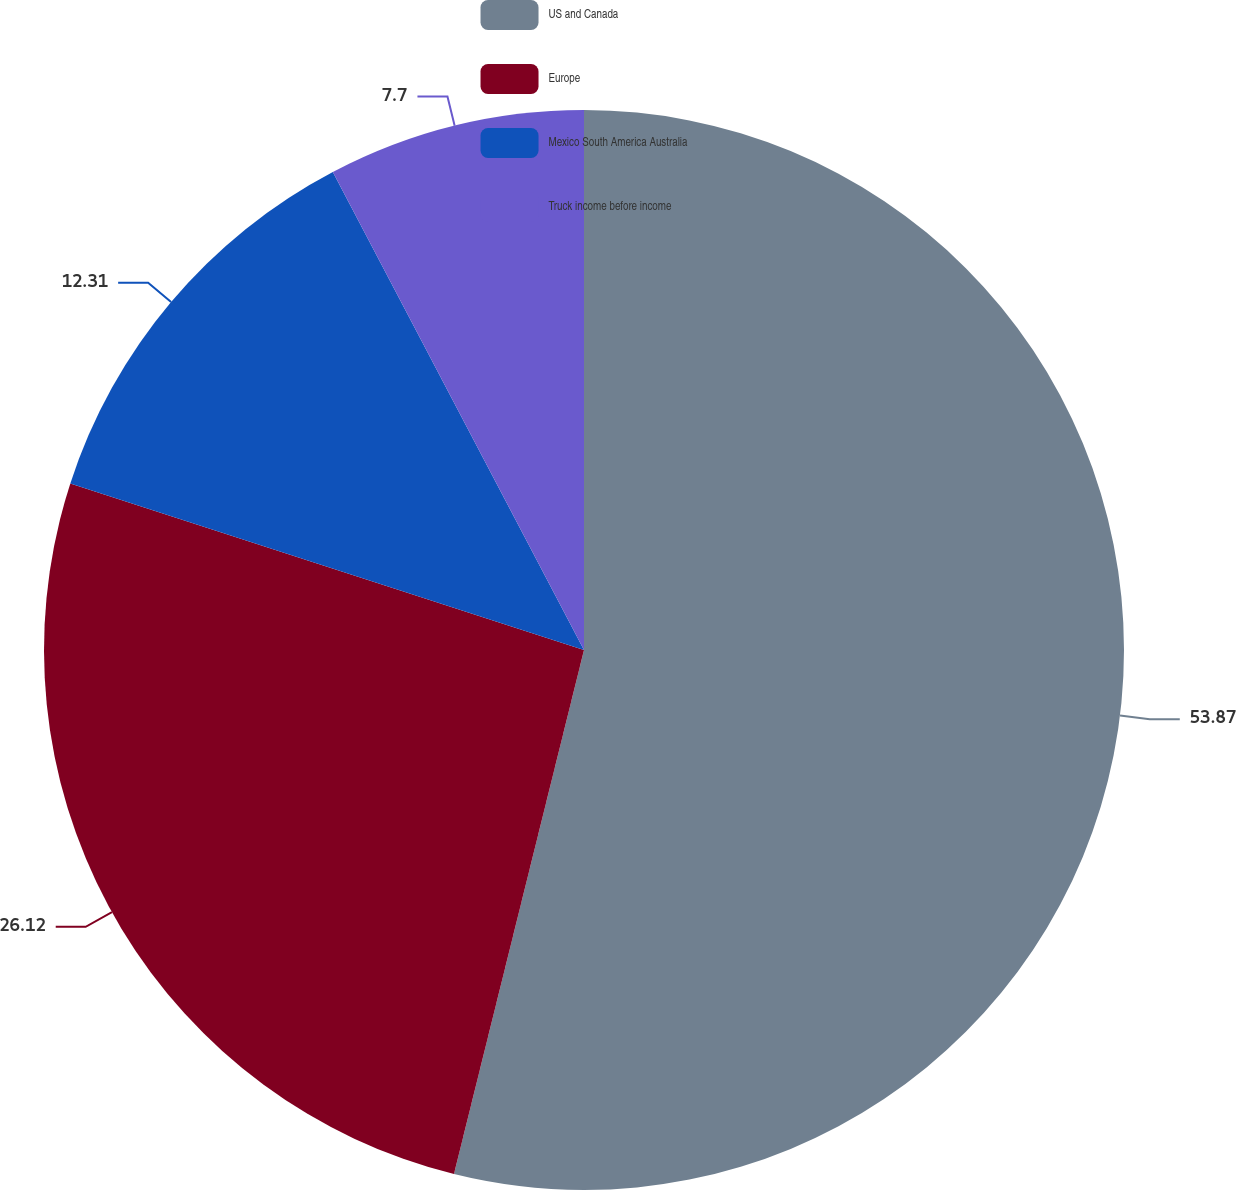Convert chart to OTSL. <chart><loc_0><loc_0><loc_500><loc_500><pie_chart><fcel>US and Canada<fcel>Europe<fcel>Mexico South America Australia<fcel>Truck income before income<nl><fcel>53.87%<fcel>26.12%<fcel>12.31%<fcel>7.7%<nl></chart> 